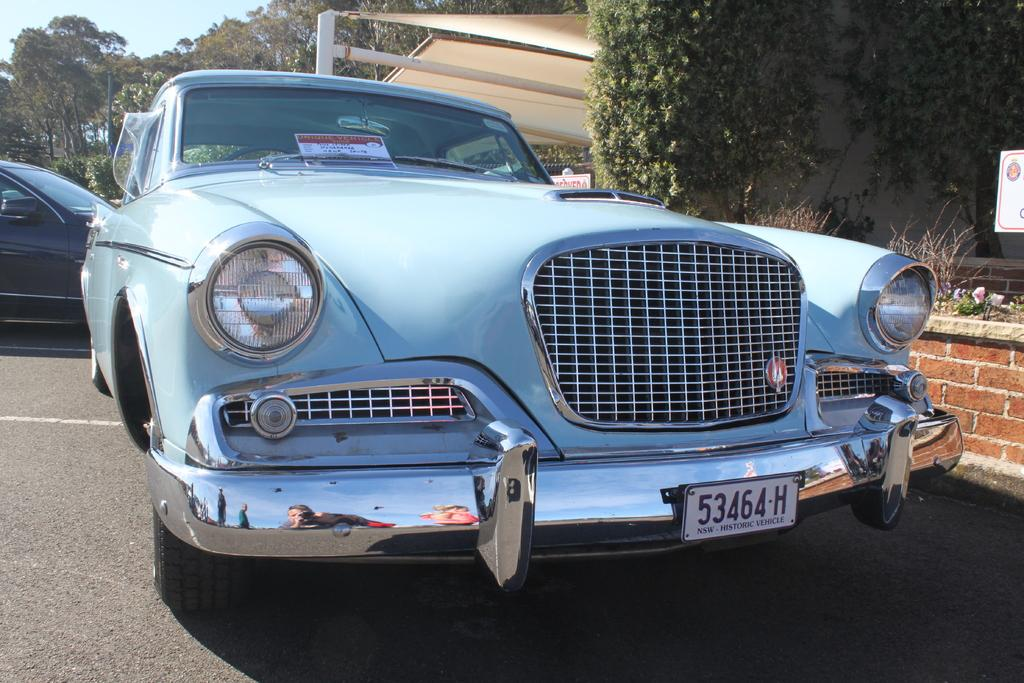What can be seen on the road in the image? There are cars on the road in the image. What is located beside the cars in the image? There is a wall beside the cars in the image. What type of vegetation is visible in the background of the image? There are trees in the background of the image. What type of structure can be seen in the background of the image? There is a shed in the background of the image. What is visible in the sky in the image? The sky is visible in the background of the image. How many squirrels are running on the wall in the image? There are no squirrels visible on the wall in the image. In which direction are the cars moving in the image? The image does not provide information about the direction in which the cars are moving. 